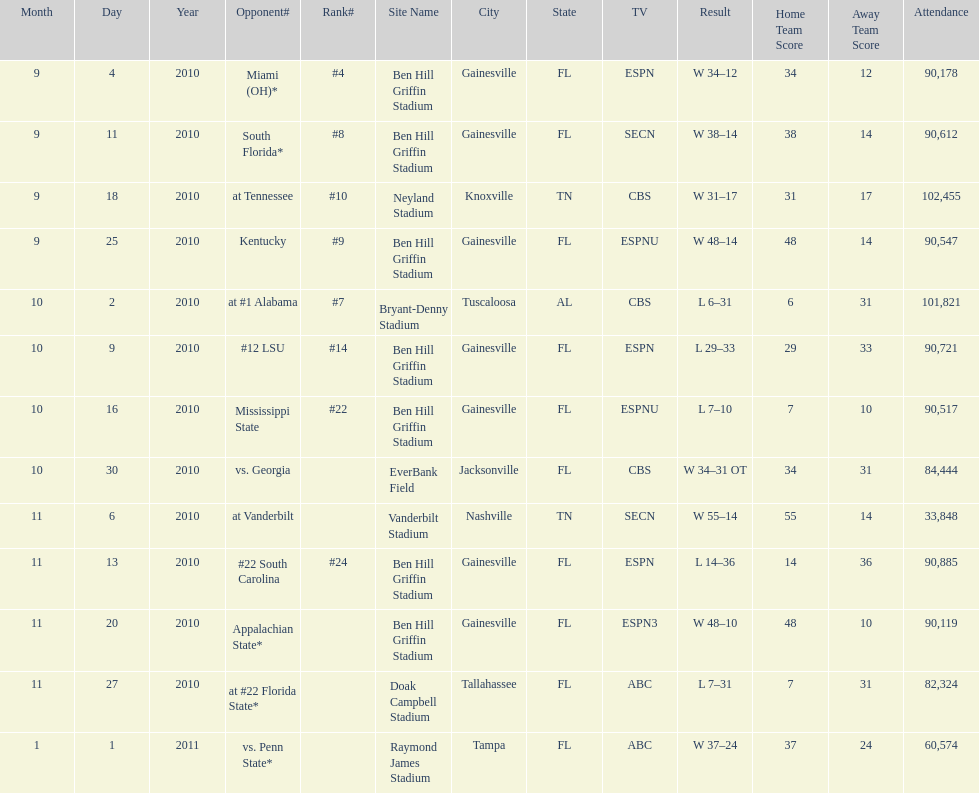The gators won the game on september 25, 2010. who won the previous game? Gators. 